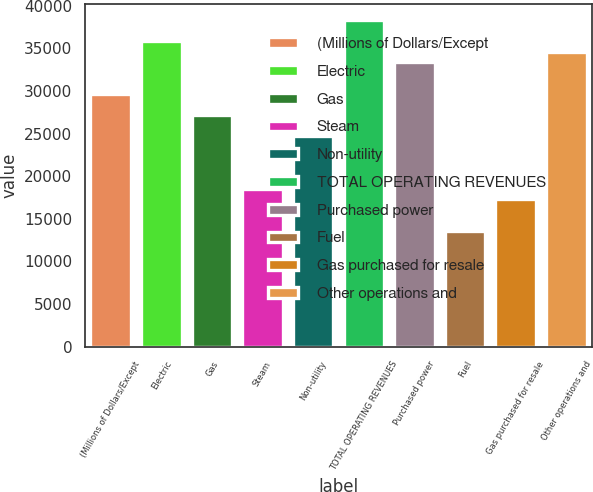Convert chart to OTSL. <chart><loc_0><loc_0><loc_500><loc_500><bar_chart><fcel>(Millions of Dollars/Except<fcel>Electric<fcel>Gas<fcel>Steam<fcel>Non-utility<fcel>TOTAL OPERATING REVENUES<fcel>Purchased power<fcel>Fuel<fcel>Gas purchased for resale<fcel>Other operations and<nl><fcel>29646.8<fcel>35822.8<fcel>27176.4<fcel>18530<fcel>24706<fcel>38293.2<fcel>33352.4<fcel>13589.2<fcel>17294.8<fcel>34587.6<nl></chart> 